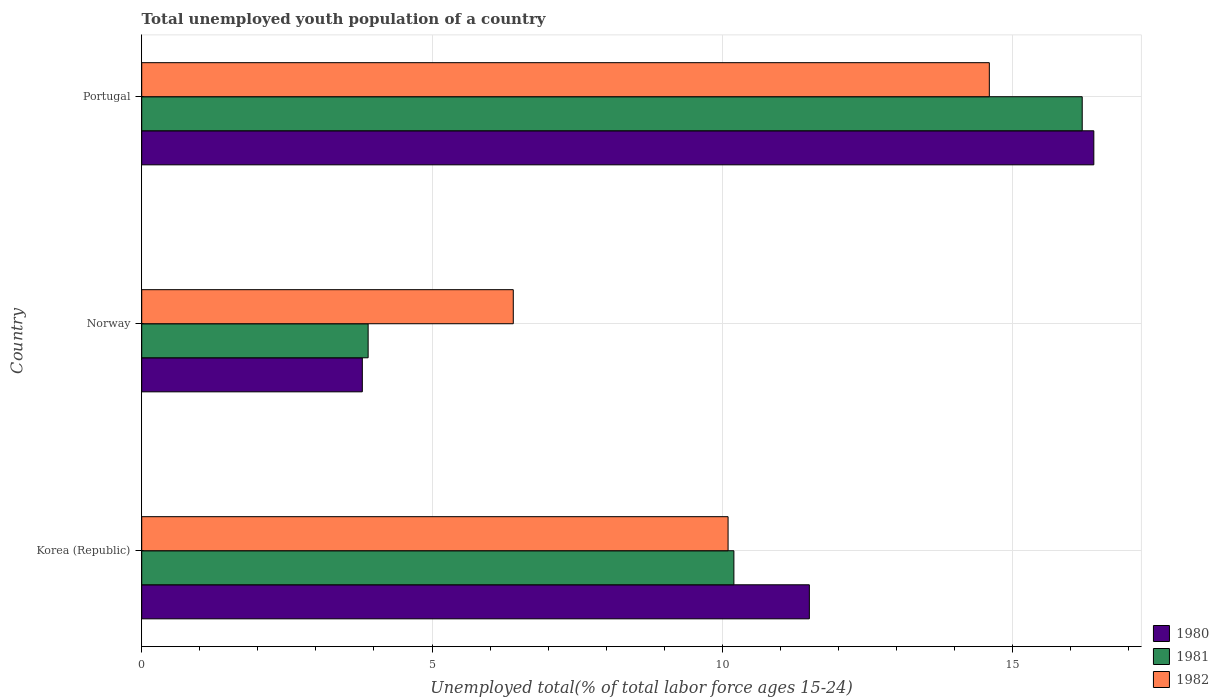How many groups of bars are there?
Your response must be concise. 3. Are the number of bars per tick equal to the number of legend labels?
Provide a succinct answer. Yes. How many bars are there on the 2nd tick from the bottom?
Provide a succinct answer. 3. In how many cases, is the number of bars for a given country not equal to the number of legend labels?
Provide a short and direct response. 0. What is the percentage of total unemployed youth population of a country in 1982 in Portugal?
Give a very brief answer. 14.6. Across all countries, what is the maximum percentage of total unemployed youth population of a country in 1980?
Your response must be concise. 16.4. Across all countries, what is the minimum percentage of total unemployed youth population of a country in 1981?
Give a very brief answer. 3.9. In which country was the percentage of total unemployed youth population of a country in 1981 minimum?
Make the answer very short. Norway. What is the total percentage of total unemployed youth population of a country in 1982 in the graph?
Give a very brief answer. 31.1. What is the difference between the percentage of total unemployed youth population of a country in 1982 in Korea (Republic) and that in Norway?
Offer a terse response. 3.7. What is the difference between the percentage of total unemployed youth population of a country in 1982 in Korea (Republic) and the percentage of total unemployed youth population of a country in 1980 in Portugal?
Your answer should be compact. -6.3. What is the average percentage of total unemployed youth population of a country in 1980 per country?
Your response must be concise. 10.57. What is the difference between the percentage of total unemployed youth population of a country in 1980 and percentage of total unemployed youth population of a country in 1981 in Korea (Republic)?
Provide a short and direct response. 1.3. What is the ratio of the percentage of total unemployed youth population of a country in 1980 in Korea (Republic) to that in Norway?
Offer a terse response. 3.03. Is the difference between the percentage of total unemployed youth population of a country in 1980 in Korea (Republic) and Portugal greater than the difference between the percentage of total unemployed youth population of a country in 1981 in Korea (Republic) and Portugal?
Provide a succinct answer. Yes. What is the difference between the highest and the second highest percentage of total unemployed youth population of a country in 1980?
Provide a short and direct response. 4.9. What is the difference between the highest and the lowest percentage of total unemployed youth population of a country in 1980?
Offer a terse response. 12.6. How many bars are there?
Ensure brevity in your answer.  9. Are all the bars in the graph horizontal?
Offer a terse response. Yes. How many countries are there in the graph?
Ensure brevity in your answer.  3. What is the difference between two consecutive major ticks on the X-axis?
Provide a short and direct response. 5. Does the graph contain any zero values?
Your answer should be very brief. No. Where does the legend appear in the graph?
Provide a succinct answer. Bottom right. How are the legend labels stacked?
Your answer should be compact. Vertical. What is the title of the graph?
Your answer should be compact. Total unemployed youth population of a country. What is the label or title of the X-axis?
Your answer should be compact. Unemployed total(% of total labor force ages 15-24). What is the label or title of the Y-axis?
Provide a succinct answer. Country. What is the Unemployed total(% of total labor force ages 15-24) of 1980 in Korea (Republic)?
Your answer should be compact. 11.5. What is the Unemployed total(% of total labor force ages 15-24) of 1981 in Korea (Republic)?
Give a very brief answer. 10.2. What is the Unemployed total(% of total labor force ages 15-24) in 1982 in Korea (Republic)?
Provide a succinct answer. 10.1. What is the Unemployed total(% of total labor force ages 15-24) of 1980 in Norway?
Give a very brief answer. 3.8. What is the Unemployed total(% of total labor force ages 15-24) of 1981 in Norway?
Offer a terse response. 3.9. What is the Unemployed total(% of total labor force ages 15-24) in 1982 in Norway?
Give a very brief answer. 6.4. What is the Unemployed total(% of total labor force ages 15-24) of 1980 in Portugal?
Provide a succinct answer. 16.4. What is the Unemployed total(% of total labor force ages 15-24) in 1981 in Portugal?
Keep it short and to the point. 16.2. What is the Unemployed total(% of total labor force ages 15-24) in 1982 in Portugal?
Keep it short and to the point. 14.6. Across all countries, what is the maximum Unemployed total(% of total labor force ages 15-24) of 1980?
Offer a terse response. 16.4. Across all countries, what is the maximum Unemployed total(% of total labor force ages 15-24) of 1981?
Offer a very short reply. 16.2. Across all countries, what is the maximum Unemployed total(% of total labor force ages 15-24) of 1982?
Offer a very short reply. 14.6. Across all countries, what is the minimum Unemployed total(% of total labor force ages 15-24) in 1980?
Offer a very short reply. 3.8. Across all countries, what is the minimum Unemployed total(% of total labor force ages 15-24) of 1981?
Give a very brief answer. 3.9. Across all countries, what is the minimum Unemployed total(% of total labor force ages 15-24) of 1982?
Offer a terse response. 6.4. What is the total Unemployed total(% of total labor force ages 15-24) in 1980 in the graph?
Offer a terse response. 31.7. What is the total Unemployed total(% of total labor force ages 15-24) of 1981 in the graph?
Offer a very short reply. 30.3. What is the total Unemployed total(% of total labor force ages 15-24) of 1982 in the graph?
Keep it short and to the point. 31.1. What is the difference between the Unemployed total(% of total labor force ages 15-24) in 1980 in Korea (Republic) and that in Norway?
Ensure brevity in your answer.  7.7. What is the difference between the Unemployed total(% of total labor force ages 15-24) in 1982 in Korea (Republic) and that in Norway?
Offer a terse response. 3.7. What is the difference between the Unemployed total(% of total labor force ages 15-24) in 1980 in Korea (Republic) and that in Portugal?
Make the answer very short. -4.9. What is the difference between the Unemployed total(% of total labor force ages 15-24) in 1980 in Korea (Republic) and the Unemployed total(% of total labor force ages 15-24) in 1981 in Norway?
Provide a succinct answer. 7.6. What is the difference between the Unemployed total(% of total labor force ages 15-24) in 1980 in Korea (Republic) and the Unemployed total(% of total labor force ages 15-24) in 1982 in Norway?
Give a very brief answer. 5.1. What is the difference between the Unemployed total(% of total labor force ages 15-24) of 1980 in Korea (Republic) and the Unemployed total(% of total labor force ages 15-24) of 1981 in Portugal?
Provide a succinct answer. -4.7. What is the difference between the Unemployed total(% of total labor force ages 15-24) of 1980 in Korea (Republic) and the Unemployed total(% of total labor force ages 15-24) of 1982 in Portugal?
Offer a terse response. -3.1. What is the difference between the Unemployed total(% of total labor force ages 15-24) in 1981 in Korea (Republic) and the Unemployed total(% of total labor force ages 15-24) in 1982 in Portugal?
Offer a terse response. -4.4. What is the difference between the Unemployed total(% of total labor force ages 15-24) in 1980 in Norway and the Unemployed total(% of total labor force ages 15-24) in 1982 in Portugal?
Provide a succinct answer. -10.8. What is the average Unemployed total(% of total labor force ages 15-24) in 1980 per country?
Offer a very short reply. 10.57. What is the average Unemployed total(% of total labor force ages 15-24) in 1982 per country?
Give a very brief answer. 10.37. What is the difference between the Unemployed total(% of total labor force ages 15-24) of 1981 and Unemployed total(% of total labor force ages 15-24) of 1982 in Korea (Republic)?
Offer a very short reply. 0.1. What is the difference between the Unemployed total(% of total labor force ages 15-24) of 1980 and Unemployed total(% of total labor force ages 15-24) of 1982 in Norway?
Offer a very short reply. -2.6. What is the difference between the Unemployed total(% of total labor force ages 15-24) of 1980 and Unemployed total(% of total labor force ages 15-24) of 1981 in Portugal?
Give a very brief answer. 0.2. What is the difference between the Unemployed total(% of total labor force ages 15-24) of 1980 and Unemployed total(% of total labor force ages 15-24) of 1982 in Portugal?
Your answer should be very brief. 1.8. What is the difference between the Unemployed total(% of total labor force ages 15-24) of 1981 and Unemployed total(% of total labor force ages 15-24) of 1982 in Portugal?
Offer a terse response. 1.6. What is the ratio of the Unemployed total(% of total labor force ages 15-24) of 1980 in Korea (Republic) to that in Norway?
Ensure brevity in your answer.  3.03. What is the ratio of the Unemployed total(% of total labor force ages 15-24) of 1981 in Korea (Republic) to that in Norway?
Give a very brief answer. 2.62. What is the ratio of the Unemployed total(% of total labor force ages 15-24) of 1982 in Korea (Republic) to that in Norway?
Keep it short and to the point. 1.58. What is the ratio of the Unemployed total(% of total labor force ages 15-24) in 1980 in Korea (Republic) to that in Portugal?
Offer a terse response. 0.7. What is the ratio of the Unemployed total(% of total labor force ages 15-24) in 1981 in Korea (Republic) to that in Portugal?
Keep it short and to the point. 0.63. What is the ratio of the Unemployed total(% of total labor force ages 15-24) in 1982 in Korea (Republic) to that in Portugal?
Provide a short and direct response. 0.69. What is the ratio of the Unemployed total(% of total labor force ages 15-24) of 1980 in Norway to that in Portugal?
Provide a succinct answer. 0.23. What is the ratio of the Unemployed total(% of total labor force ages 15-24) in 1981 in Norway to that in Portugal?
Give a very brief answer. 0.24. What is the ratio of the Unemployed total(% of total labor force ages 15-24) of 1982 in Norway to that in Portugal?
Make the answer very short. 0.44. What is the difference between the highest and the second highest Unemployed total(% of total labor force ages 15-24) of 1981?
Keep it short and to the point. 6. What is the difference between the highest and the second highest Unemployed total(% of total labor force ages 15-24) of 1982?
Provide a short and direct response. 4.5. What is the difference between the highest and the lowest Unemployed total(% of total labor force ages 15-24) in 1980?
Offer a terse response. 12.6. 